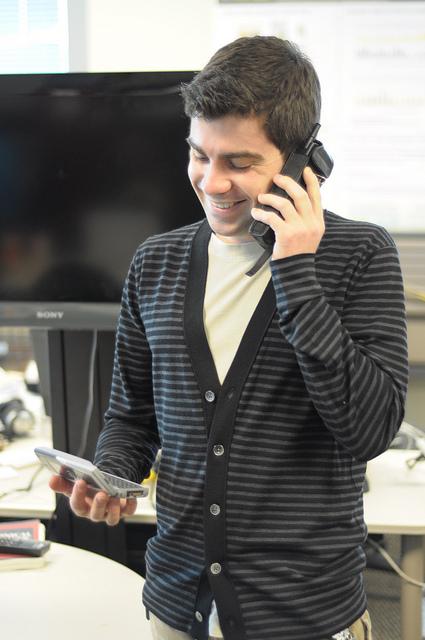Does this man look serious?
Concise answer only. No. What is the man talking on?
Quick response, please. Phone. How many televisions are in the picture?
Short answer required. 1. What type of electronic device is the man in the photo featured with?
Answer briefly. Cell phone. How many buttons are on the man's shirt?
Give a very brief answer. 5. 